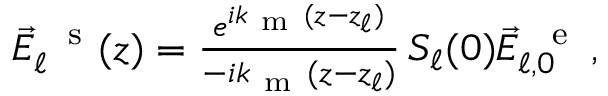<formula> <loc_0><loc_0><loc_500><loc_500>\begin{array} { r } { \vec { E } _ { \ell } ^ { \, s } ( z ) = \frac { e ^ { i k _ { m } ( z - z _ { \ell } ) } } { - i k _ { m } ( z - z _ { \ell } ) } \, S _ { \ell } ( 0 ) \vec { E } _ { \ell , 0 } ^ { \, e } \, , } \end{array}</formula> 